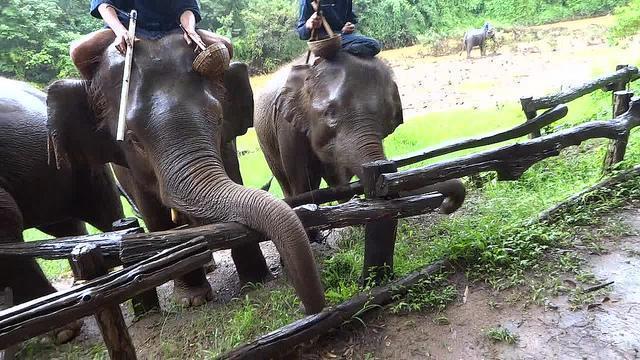What animals are present in the image?
Indicate the correct response and explain using: 'Answer: answer
Rationale: rationale.'
Options: Elephant, giraffe, tiger, bear. Answer: elephant.
Rationale: The size, colour, and distinguishable trunk cannot be seen on any other animal. 